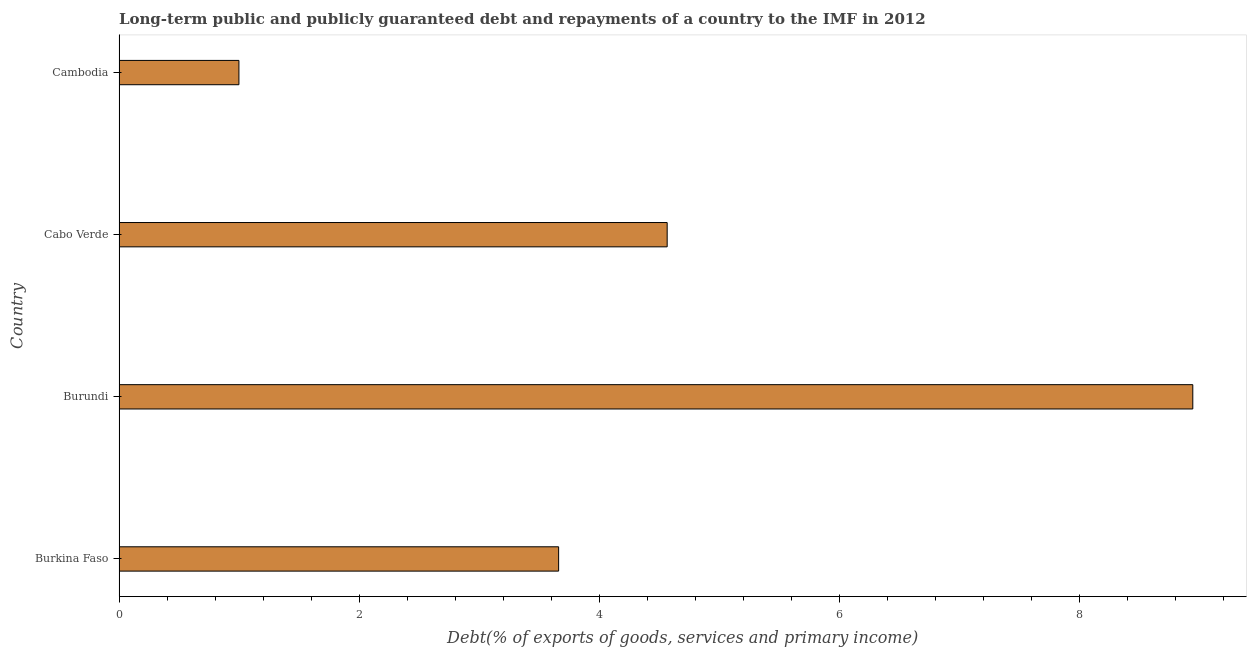Does the graph contain grids?
Offer a very short reply. No. What is the title of the graph?
Give a very brief answer. Long-term public and publicly guaranteed debt and repayments of a country to the IMF in 2012. What is the label or title of the X-axis?
Offer a terse response. Debt(% of exports of goods, services and primary income). What is the debt service in Burkina Faso?
Make the answer very short. 3.66. Across all countries, what is the maximum debt service?
Ensure brevity in your answer.  8.94. Across all countries, what is the minimum debt service?
Keep it short and to the point. 1. In which country was the debt service maximum?
Your answer should be compact. Burundi. In which country was the debt service minimum?
Your answer should be compact. Cambodia. What is the sum of the debt service?
Give a very brief answer. 18.17. What is the difference between the debt service in Cabo Verde and Cambodia?
Keep it short and to the point. 3.57. What is the average debt service per country?
Ensure brevity in your answer.  4.54. What is the median debt service?
Give a very brief answer. 4.11. In how many countries, is the debt service greater than 3.2 %?
Provide a short and direct response. 3. What is the ratio of the debt service in Cabo Verde to that in Cambodia?
Provide a succinct answer. 4.57. Is the debt service in Burkina Faso less than that in Cambodia?
Provide a succinct answer. No. What is the difference between the highest and the second highest debt service?
Offer a terse response. 4.38. What is the difference between the highest and the lowest debt service?
Your answer should be compact. 7.94. How many bars are there?
Your response must be concise. 4. Are all the bars in the graph horizontal?
Make the answer very short. Yes. How many countries are there in the graph?
Keep it short and to the point. 4. What is the difference between two consecutive major ticks on the X-axis?
Offer a very short reply. 2. Are the values on the major ticks of X-axis written in scientific E-notation?
Your answer should be very brief. No. What is the Debt(% of exports of goods, services and primary income) in Burkina Faso?
Your response must be concise. 3.66. What is the Debt(% of exports of goods, services and primary income) in Burundi?
Provide a short and direct response. 8.94. What is the Debt(% of exports of goods, services and primary income) in Cabo Verde?
Keep it short and to the point. 4.56. What is the Debt(% of exports of goods, services and primary income) of Cambodia?
Give a very brief answer. 1. What is the difference between the Debt(% of exports of goods, services and primary income) in Burkina Faso and Burundi?
Keep it short and to the point. -5.28. What is the difference between the Debt(% of exports of goods, services and primary income) in Burkina Faso and Cabo Verde?
Ensure brevity in your answer.  -0.9. What is the difference between the Debt(% of exports of goods, services and primary income) in Burkina Faso and Cambodia?
Make the answer very short. 2.66. What is the difference between the Debt(% of exports of goods, services and primary income) in Burundi and Cabo Verde?
Your answer should be compact. 4.38. What is the difference between the Debt(% of exports of goods, services and primary income) in Burundi and Cambodia?
Your answer should be very brief. 7.94. What is the difference between the Debt(% of exports of goods, services and primary income) in Cabo Verde and Cambodia?
Offer a very short reply. 3.57. What is the ratio of the Debt(% of exports of goods, services and primary income) in Burkina Faso to that in Burundi?
Keep it short and to the point. 0.41. What is the ratio of the Debt(% of exports of goods, services and primary income) in Burkina Faso to that in Cabo Verde?
Make the answer very short. 0.8. What is the ratio of the Debt(% of exports of goods, services and primary income) in Burkina Faso to that in Cambodia?
Ensure brevity in your answer.  3.67. What is the ratio of the Debt(% of exports of goods, services and primary income) in Burundi to that in Cabo Verde?
Provide a short and direct response. 1.96. What is the ratio of the Debt(% of exports of goods, services and primary income) in Burundi to that in Cambodia?
Provide a succinct answer. 8.96. What is the ratio of the Debt(% of exports of goods, services and primary income) in Cabo Verde to that in Cambodia?
Offer a terse response. 4.57. 